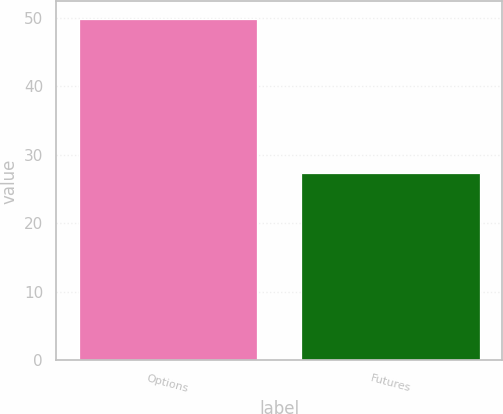Convert chart to OTSL. <chart><loc_0><loc_0><loc_500><loc_500><bar_chart><fcel>Options<fcel>Futures<nl><fcel>49.9<fcel>27.3<nl></chart> 